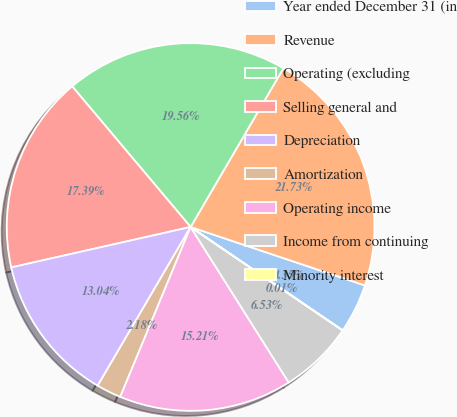Convert chart to OTSL. <chart><loc_0><loc_0><loc_500><loc_500><pie_chart><fcel>Year ended December 31 (in<fcel>Revenue<fcel>Operating (excluding<fcel>Selling general and<fcel>Depreciation<fcel>Amortization<fcel>Operating income<fcel>Income from continuing<fcel>Minority interest<nl><fcel>4.35%<fcel>21.73%<fcel>19.56%<fcel>17.39%<fcel>13.04%<fcel>2.18%<fcel>15.21%<fcel>6.53%<fcel>0.01%<nl></chart> 